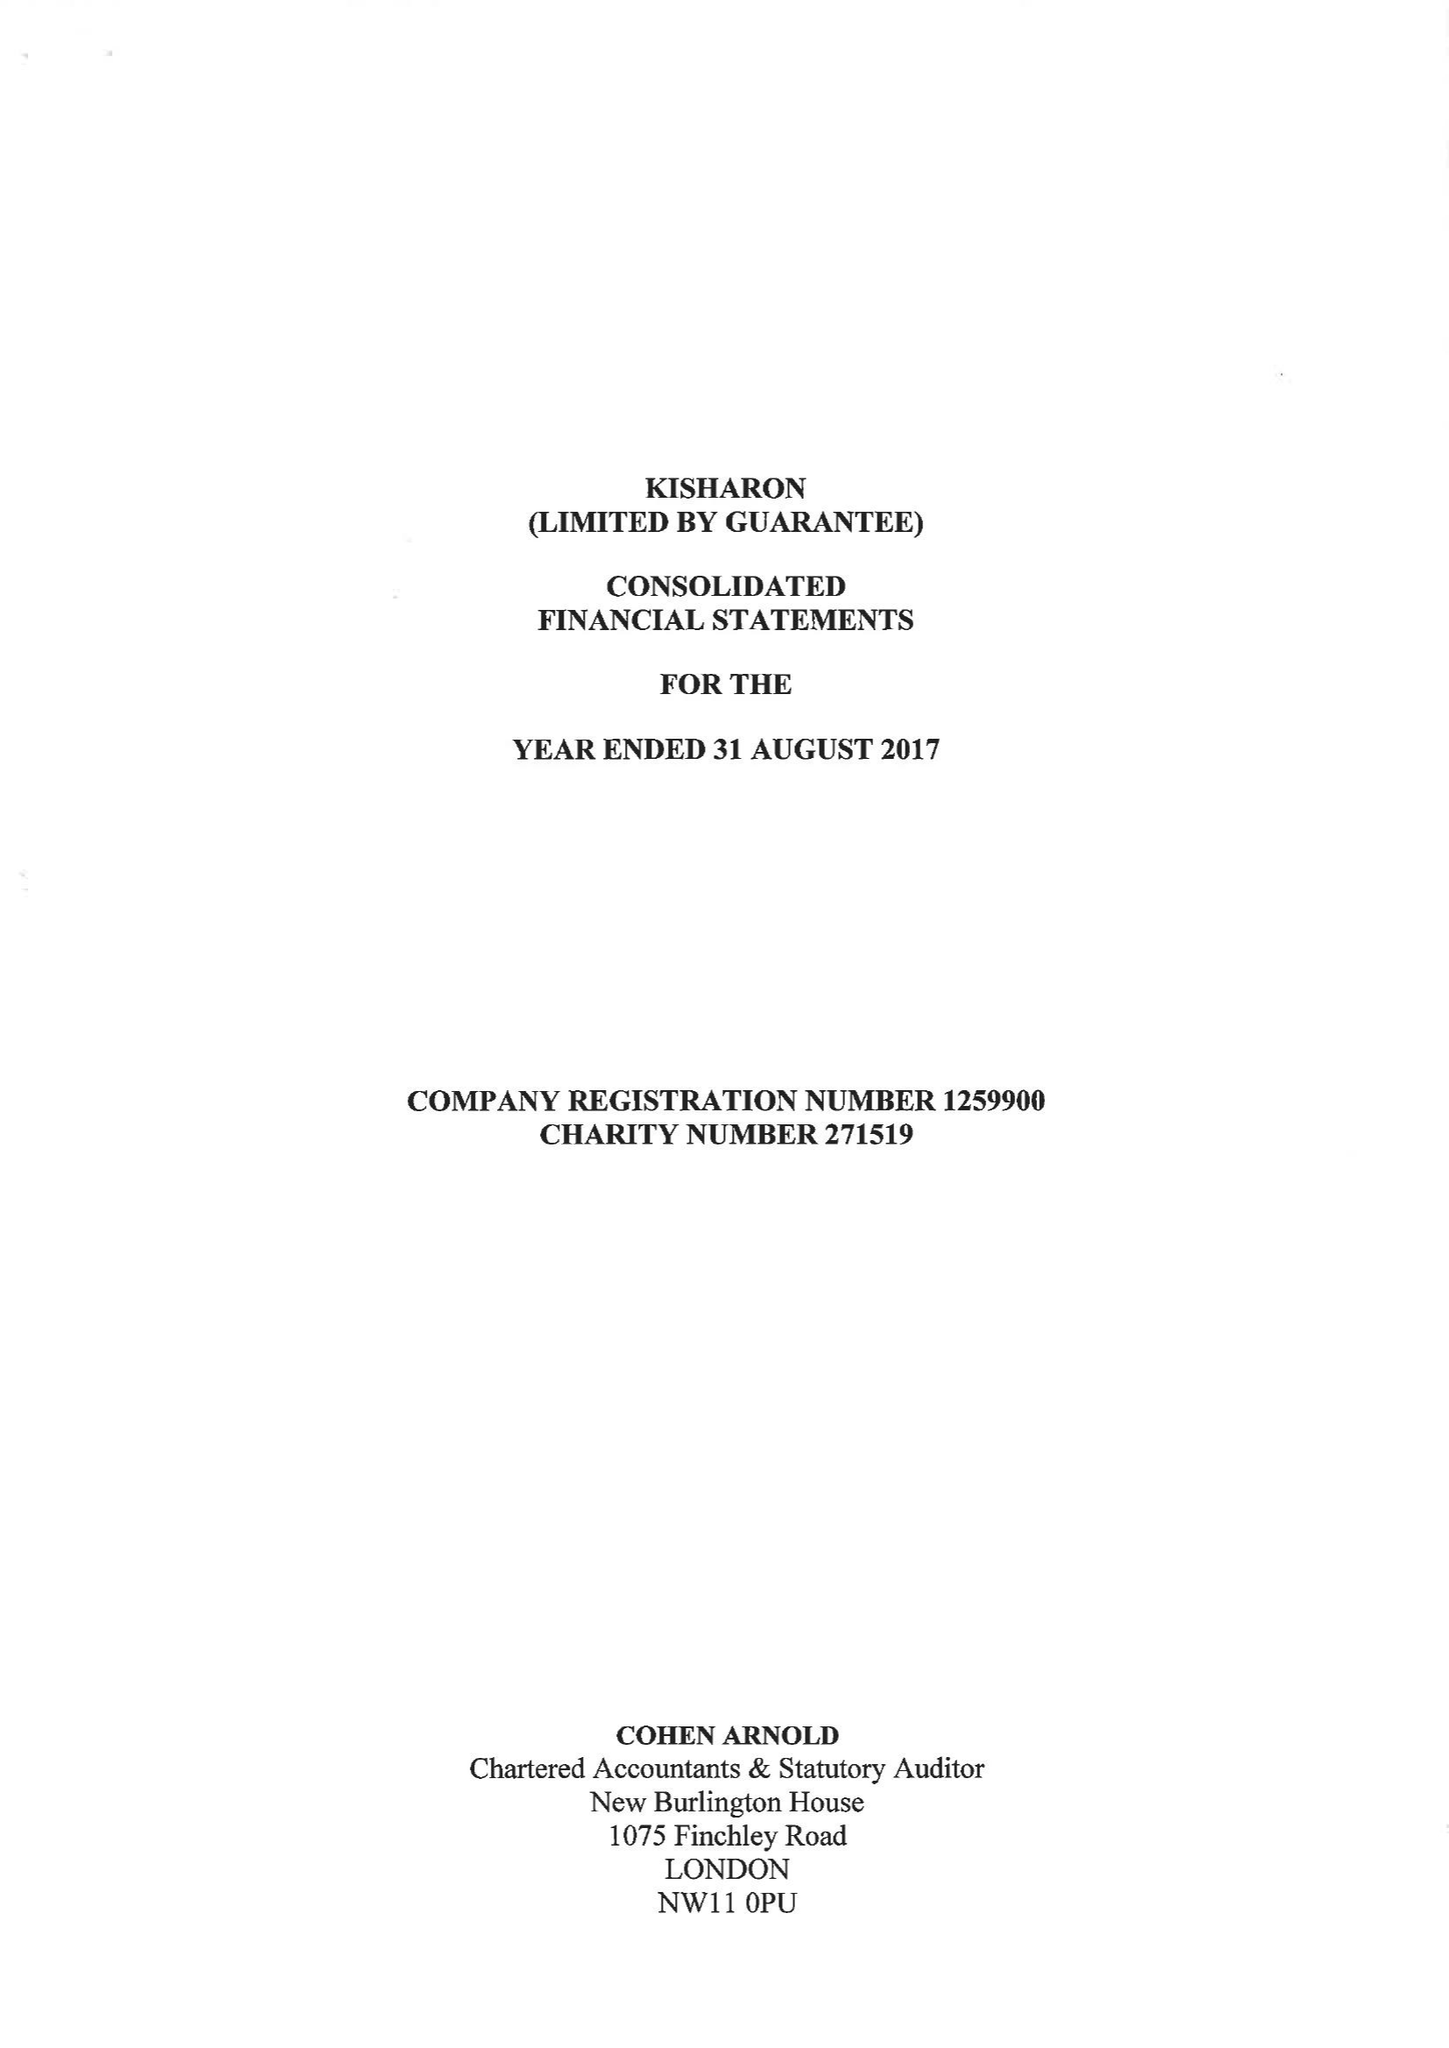What is the value for the spending_annually_in_british_pounds?
Answer the question using a single word or phrase. 6138822.00 